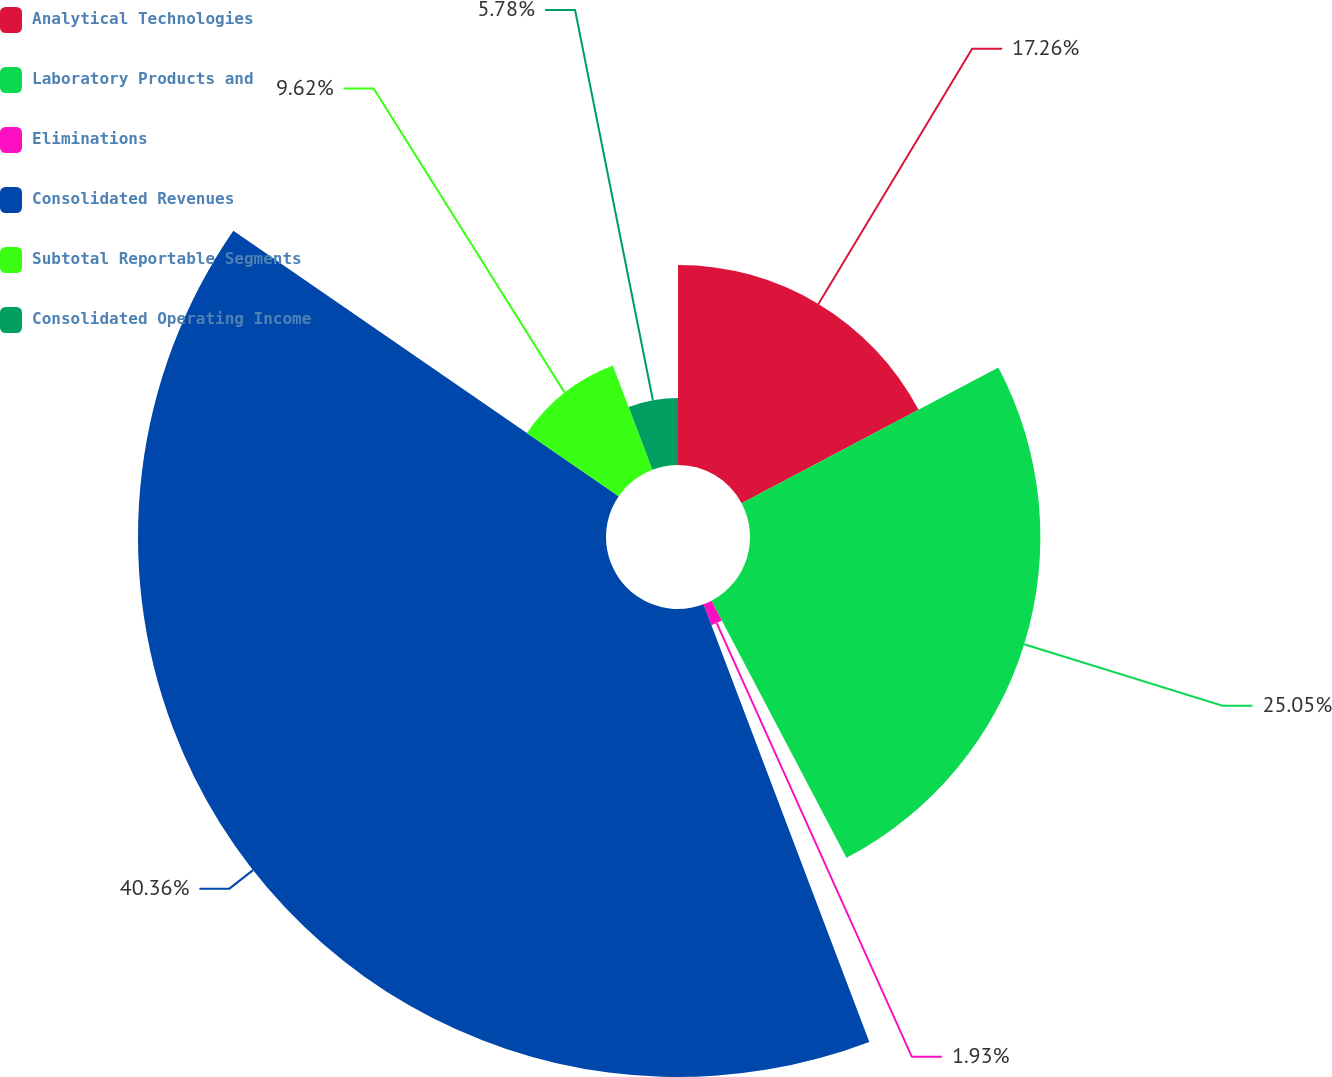<chart> <loc_0><loc_0><loc_500><loc_500><pie_chart><fcel>Analytical Technologies<fcel>Laboratory Products and<fcel>Eliminations<fcel>Consolidated Revenues<fcel>Subtotal Reportable Segments<fcel>Consolidated Operating Income<nl><fcel>17.26%<fcel>25.05%<fcel>1.93%<fcel>40.37%<fcel>9.62%<fcel>5.78%<nl></chart> 